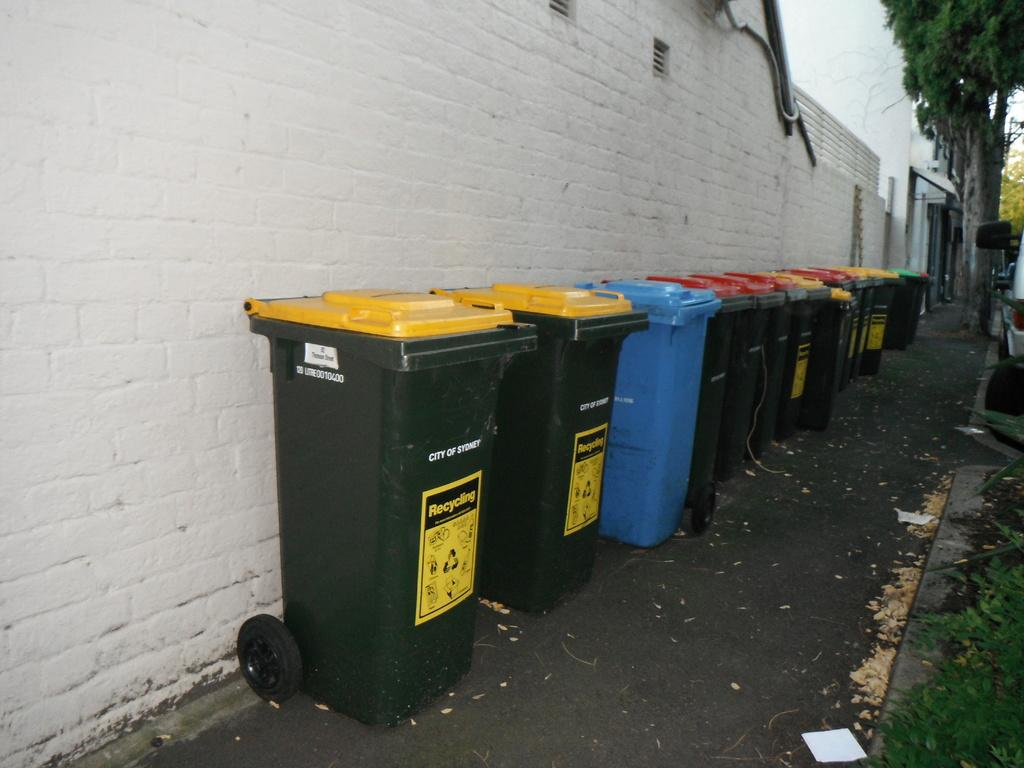Provide a one-sentence caption for the provided image. A series of recycling cans against a white wall from the City of Sydney. 